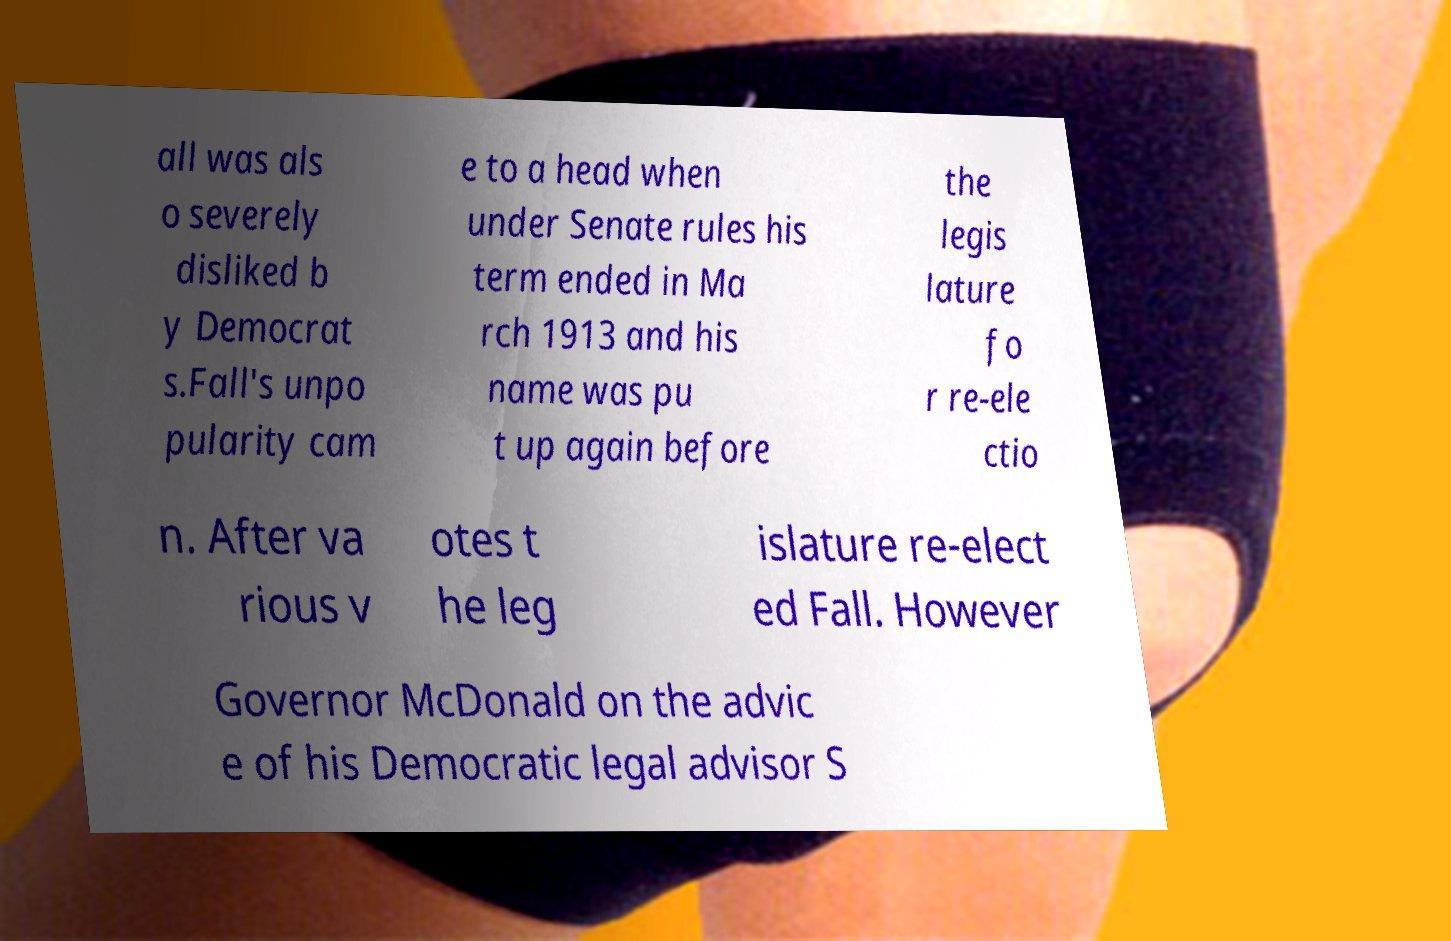Can you accurately transcribe the text from the provided image for me? all was als o severely disliked b y Democrat s.Fall's unpo pularity cam e to a head when under Senate rules his term ended in Ma rch 1913 and his name was pu t up again before the legis lature fo r re-ele ctio n. After va rious v otes t he leg islature re-elect ed Fall. However Governor McDonald on the advic e of his Democratic legal advisor S 